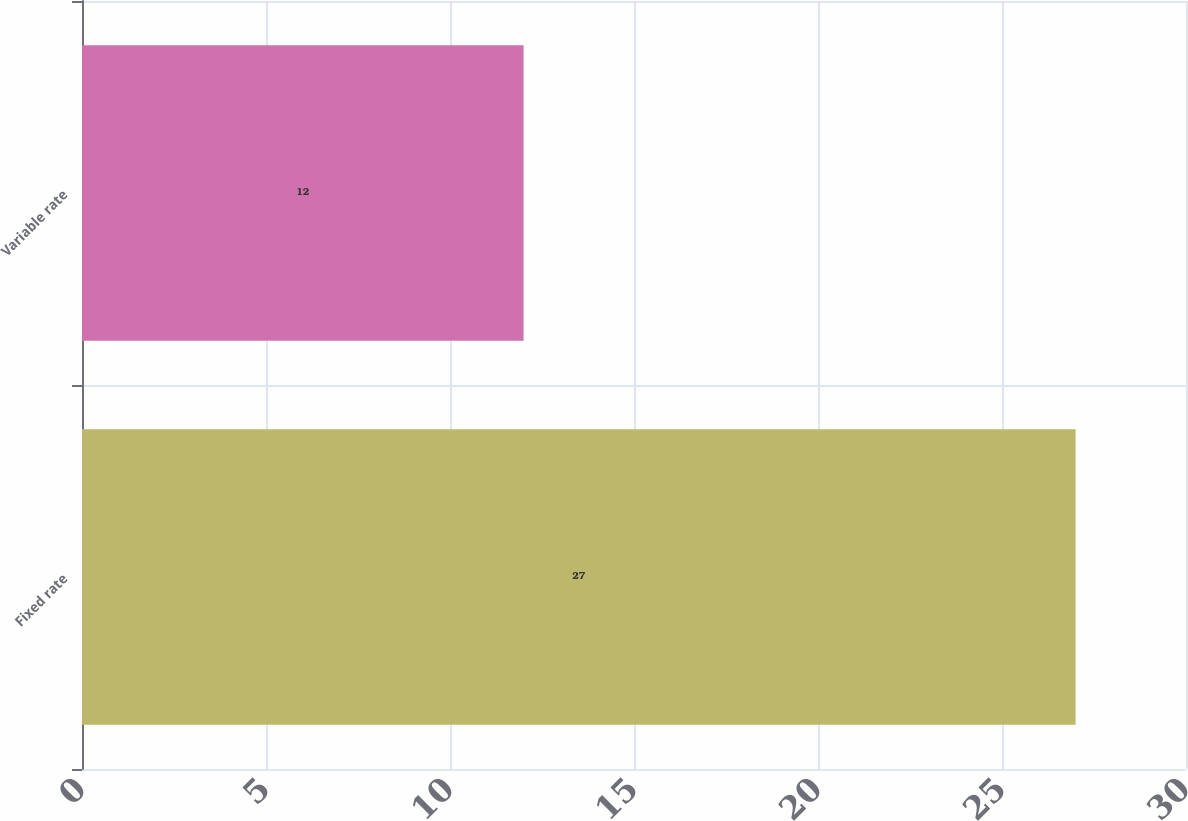<chart> <loc_0><loc_0><loc_500><loc_500><bar_chart><fcel>Fixed rate<fcel>Variable rate<nl><fcel>27<fcel>12<nl></chart> 